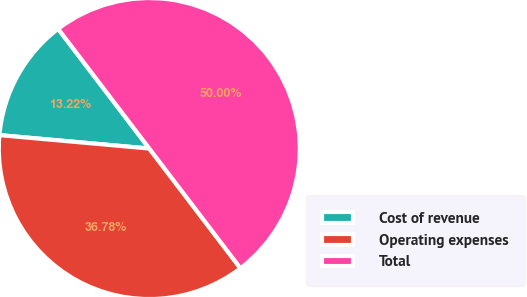Convert chart to OTSL. <chart><loc_0><loc_0><loc_500><loc_500><pie_chart><fcel>Cost of revenue<fcel>Operating expenses<fcel>Total<nl><fcel>13.22%<fcel>36.78%<fcel>50.0%<nl></chart> 